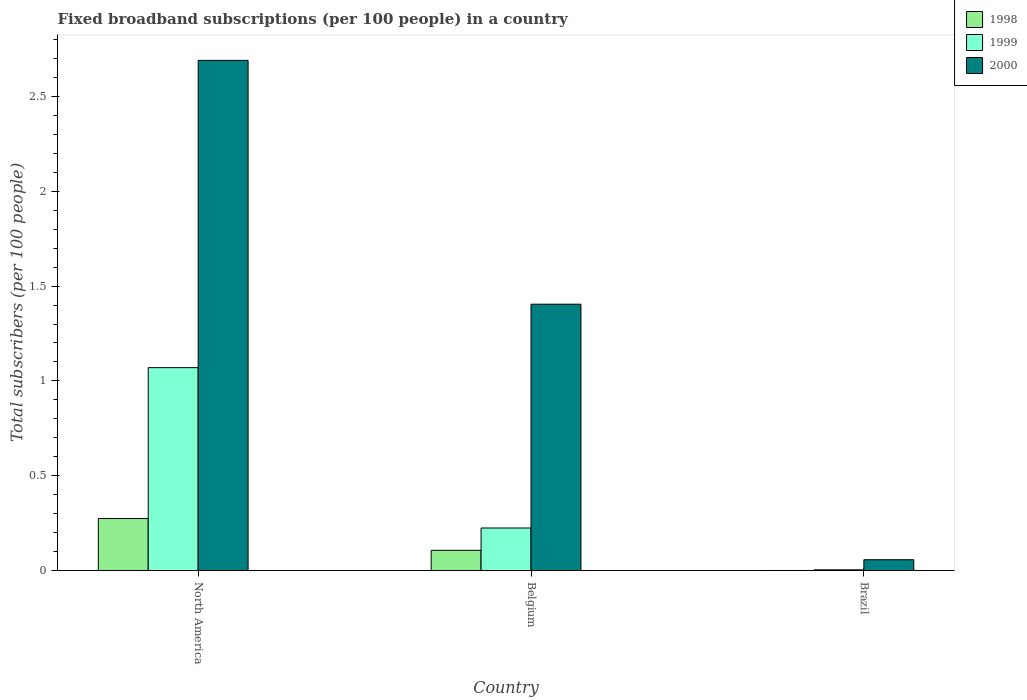Are the number of bars per tick equal to the number of legend labels?
Provide a short and direct response. Yes. Are the number of bars on each tick of the X-axis equal?
Offer a very short reply. Yes. In how many cases, is the number of bars for a given country not equal to the number of legend labels?
Ensure brevity in your answer.  0. What is the number of broadband subscriptions in 2000 in Brazil?
Keep it short and to the point. 0.06. Across all countries, what is the maximum number of broadband subscriptions in 2000?
Offer a terse response. 2.69. Across all countries, what is the minimum number of broadband subscriptions in 1998?
Your response must be concise. 0. In which country was the number of broadband subscriptions in 2000 maximum?
Offer a terse response. North America. What is the total number of broadband subscriptions in 1998 in the graph?
Ensure brevity in your answer.  0.38. What is the difference between the number of broadband subscriptions in 2000 in Belgium and that in North America?
Offer a very short reply. -1.29. What is the difference between the number of broadband subscriptions in 1999 in North America and the number of broadband subscriptions in 2000 in Brazil?
Provide a succinct answer. 1.01. What is the average number of broadband subscriptions in 2000 per country?
Offer a very short reply. 1.38. What is the difference between the number of broadband subscriptions of/in 1999 and number of broadband subscriptions of/in 2000 in North America?
Your answer should be very brief. -1.62. In how many countries, is the number of broadband subscriptions in 2000 greater than 0.30000000000000004?
Keep it short and to the point. 2. What is the ratio of the number of broadband subscriptions in 1999 in Belgium to that in Brazil?
Make the answer very short. 55.18. Is the difference between the number of broadband subscriptions in 1999 in Belgium and Brazil greater than the difference between the number of broadband subscriptions in 2000 in Belgium and Brazil?
Your answer should be compact. No. What is the difference between the highest and the second highest number of broadband subscriptions in 1998?
Ensure brevity in your answer.  0.17. What is the difference between the highest and the lowest number of broadband subscriptions in 1999?
Provide a short and direct response. 1.07. Is it the case that in every country, the sum of the number of broadband subscriptions in 1999 and number of broadband subscriptions in 1998 is greater than the number of broadband subscriptions in 2000?
Ensure brevity in your answer.  No. How many bars are there?
Give a very brief answer. 9. Are all the bars in the graph horizontal?
Make the answer very short. No. How many countries are there in the graph?
Offer a terse response. 3. What is the difference between two consecutive major ticks on the Y-axis?
Offer a very short reply. 0.5. Does the graph contain any zero values?
Your answer should be compact. No. Does the graph contain grids?
Ensure brevity in your answer.  No. Where does the legend appear in the graph?
Give a very brief answer. Top right. What is the title of the graph?
Your answer should be very brief. Fixed broadband subscriptions (per 100 people) in a country. Does "1999" appear as one of the legend labels in the graph?
Your response must be concise. Yes. What is the label or title of the X-axis?
Make the answer very short. Country. What is the label or title of the Y-axis?
Offer a very short reply. Total subscribers (per 100 people). What is the Total subscribers (per 100 people) of 1998 in North America?
Provide a succinct answer. 0.27. What is the Total subscribers (per 100 people) in 1999 in North America?
Keep it short and to the point. 1.07. What is the Total subscribers (per 100 people) in 2000 in North America?
Your answer should be very brief. 2.69. What is the Total subscribers (per 100 people) of 1998 in Belgium?
Your answer should be very brief. 0.11. What is the Total subscribers (per 100 people) of 1999 in Belgium?
Make the answer very short. 0.22. What is the Total subscribers (per 100 people) of 2000 in Belgium?
Your response must be concise. 1.4. What is the Total subscribers (per 100 people) in 1998 in Brazil?
Provide a short and direct response. 0. What is the Total subscribers (per 100 people) of 1999 in Brazil?
Offer a terse response. 0. What is the Total subscribers (per 100 people) of 2000 in Brazil?
Make the answer very short. 0.06. Across all countries, what is the maximum Total subscribers (per 100 people) of 1998?
Your answer should be compact. 0.27. Across all countries, what is the maximum Total subscribers (per 100 people) in 1999?
Your response must be concise. 1.07. Across all countries, what is the maximum Total subscribers (per 100 people) of 2000?
Make the answer very short. 2.69. Across all countries, what is the minimum Total subscribers (per 100 people) in 1998?
Your answer should be compact. 0. Across all countries, what is the minimum Total subscribers (per 100 people) of 1999?
Your answer should be very brief. 0. Across all countries, what is the minimum Total subscribers (per 100 people) of 2000?
Make the answer very short. 0.06. What is the total Total subscribers (per 100 people) of 1998 in the graph?
Provide a succinct answer. 0.38. What is the total Total subscribers (per 100 people) of 1999 in the graph?
Offer a very short reply. 1.3. What is the total Total subscribers (per 100 people) in 2000 in the graph?
Keep it short and to the point. 4.15. What is the difference between the Total subscribers (per 100 people) of 1998 in North America and that in Belgium?
Make the answer very short. 0.17. What is the difference between the Total subscribers (per 100 people) in 1999 in North America and that in Belgium?
Provide a succinct answer. 0.85. What is the difference between the Total subscribers (per 100 people) in 2000 in North America and that in Belgium?
Offer a very short reply. 1.29. What is the difference between the Total subscribers (per 100 people) in 1998 in North America and that in Brazil?
Keep it short and to the point. 0.27. What is the difference between the Total subscribers (per 100 people) of 1999 in North America and that in Brazil?
Your answer should be compact. 1.07. What is the difference between the Total subscribers (per 100 people) of 2000 in North America and that in Brazil?
Your answer should be very brief. 2.63. What is the difference between the Total subscribers (per 100 people) of 1998 in Belgium and that in Brazil?
Provide a succinct answer. 0.11. What is the difference between the Total subscribers (per 100 people) of 1999 in Belgium and that in Brazil?
Provide a succinct answer. 0.22. What is the difference between the Total subscribers (per 100 people) in 2000 in Belgium and that in Brazil?
Ensure brevity in your answer.  1.35. What is the difference between the Total subscribers (per 100 people) in 1998 in North America and the Total subscribers (per 100 people) in 1999 in Belgium?
Offer a terse response. 0.05. What is the difference between the Total subscribers (per 100 people) of 1998 in North America and the Total subscribers (per 100 people) of 2000 in Belgium?
Ensure brevity in your answer.  -1.13. What is the difference between the Total subscribers (per 100 people) of 1999 in North America and the Total subscribers (per 100 people) of 2000 in Belgium?
Your answer should be very brief. -0.33. What is the difference between the Total subscribers (per 100 people) of 1998 in North America and the Total subscribers (per 100 people) of 1999 in Brazil?
Provide a short and direct response. 0.27. What is the difference between the Total subscribers (per 100 people) in 1998 in North America and the Total subscribers (per 100 people) in 2000 in Brazil?
Your response must be concise. 0.22. What is the difference between the Total subscribers (per 100 people) in 1999 in North America and the Total subscribers (per 100 people) in 2000 in Brazil?
Keep it short and to the point. 1.01. What is the difference between the Total subscribers (per 100 people) in 1998 in Belgium and the Total subscribers (per 100 people) in 1999 in Brazil?
Offer a terse response. 0.1. What is the difference between the Total subscribers (per 100 people) of 1998 in Belgium and the Total subscribers (per 100 people) of 2000 in Brazil?
Your response must be concise. 0.05. What is the difference between the Total subscribers (per 100 people) in 1999 in Belgium and the Total subscribers (per 100 people) in 2000 in Brazil?
Offer a very short reply. 0.17. What is the average Total subscribers (per 100 people) in 1998 per country?
Offer a terse response. 0.13. What is the average Total subscribers (per 100 people) of 1999 per country?
Provide a short and direct response. 0.43. What is the average Total subscribers (per 100 people) in 2000 per country?
Your response must be concise. 1.38. What is the difference between the Total subscribers (per 100 people) of 1998 and Total subscribers (per 100 people) of 1999 in North America?
Ensure brevity in your answer.  -0.8. What is the difference between the Total subscribers (per 100 people) of 1998 and Total subscribers (per 100 people) of 2000 in North America?
Give a very brief answer. -2.42. What is the difference between the Total subscribers (per 100 people) of 1999 and Total subscribers (per 100 people) of 2000 in North America?
Give a very brief answer. -1.62. What is the difference between the Total subscribers (per 100 people) in 1998 and Total subscribers (per 100 people) in 1999 in Belgium?
Provide a succinct answer. -0.12. What is the difference between the Total subscribers (per 100 people) in 1998 and Total subscribers (per 100 people) in 2000 in Belgium?
Provide a short and direct response. -1.3. What is the difference between the Total subscribers (per 100 people) of 1999 and Total subscribers (per 100 people) of 2000 in Belgium?
Ensure brevity in your answer.  -1.18. What is the difference between the Total subscribers (per 100 people) in 1998 and Total subscribers (per 100 people) in 1999 in Brazil?
Provide a succinct answer. -0. What is the difference between the Total subscribers (per 100 people) in 1998 and Total subscribers (per 100 people) in 2000 in Brazil?
Ensure brevity in your answer.  -0.06. What is the difference between the Total subscribers (per 100 people) in 1999 and Total subscribers (per 100 people) in 2000 in Brazil?
Offer a very short reply. -0.05. What is the ratio of the Total subscribers (per 100 people) of 1998 in North America to that in Belgium?
Provide a short and direct response. 2.57. What is the ratio of the Total subscribers (per 100 people) in 1999 in North America to that in Belgium?
Keep it short and to the point. 4.76. What is the ratio of the Total subscribers (per 100 people) of 2000 in North America to that in Belgium?
Provide a short and direct response. 1.92. What is the ratio of the Total subscribers (per 100 people) in 1998 in North America to that in Brazil?
Keep it short and to the point. 465.15. What is the ratio of the Total subscribers (per 100 people) of 1999 in North America to that in Brazil?
Provide a succinct answer. 262.9. What is the ratio of the Total subscribers (per 100 people) of 2000 in North America to that in Brazil?
Offer a terse response. 46.94. What is the ratio of the Total subscribers (per 100 people) of 1998 in Belgium to that in Brazil?
Your response must be concise. 181.1. What is the ratio of the Total subscribers (per 100 people) in 1999 in Belgium to that in Brazil?
Offer a terse response. 55.18. What is the ratio of the Total subscribers (per 100 people) of 2000 in Belgium to that in Brazil?
Offer a very short reply. 24.51. What is the difference between the highest and the second highest Total subscribers (per 100 people) in 1998?
Provide a short and direct response. 0.17. What is the difference between the highest and the second highest Total subscribers (per 100 people) in 1999?
Give a very brief answer. 0.85. What is the difference between the highest and the second highest Total subscribers (per 100 people) of 2000?
Give a very brief answer. 1.29. What is the difference between the highest and the lowest Total subscribers (per 100 people) in 1998?
Your answer should be compact. 0.27. What is the difference between the highest and the lowest Total subscribers (per 100 people) of 1999?
Offer a very short reply. 1.07. What is the difference between the highest and the lowest Total subscribers (per 100 people) of 2000?
Offer a very short reply. 2.63. 